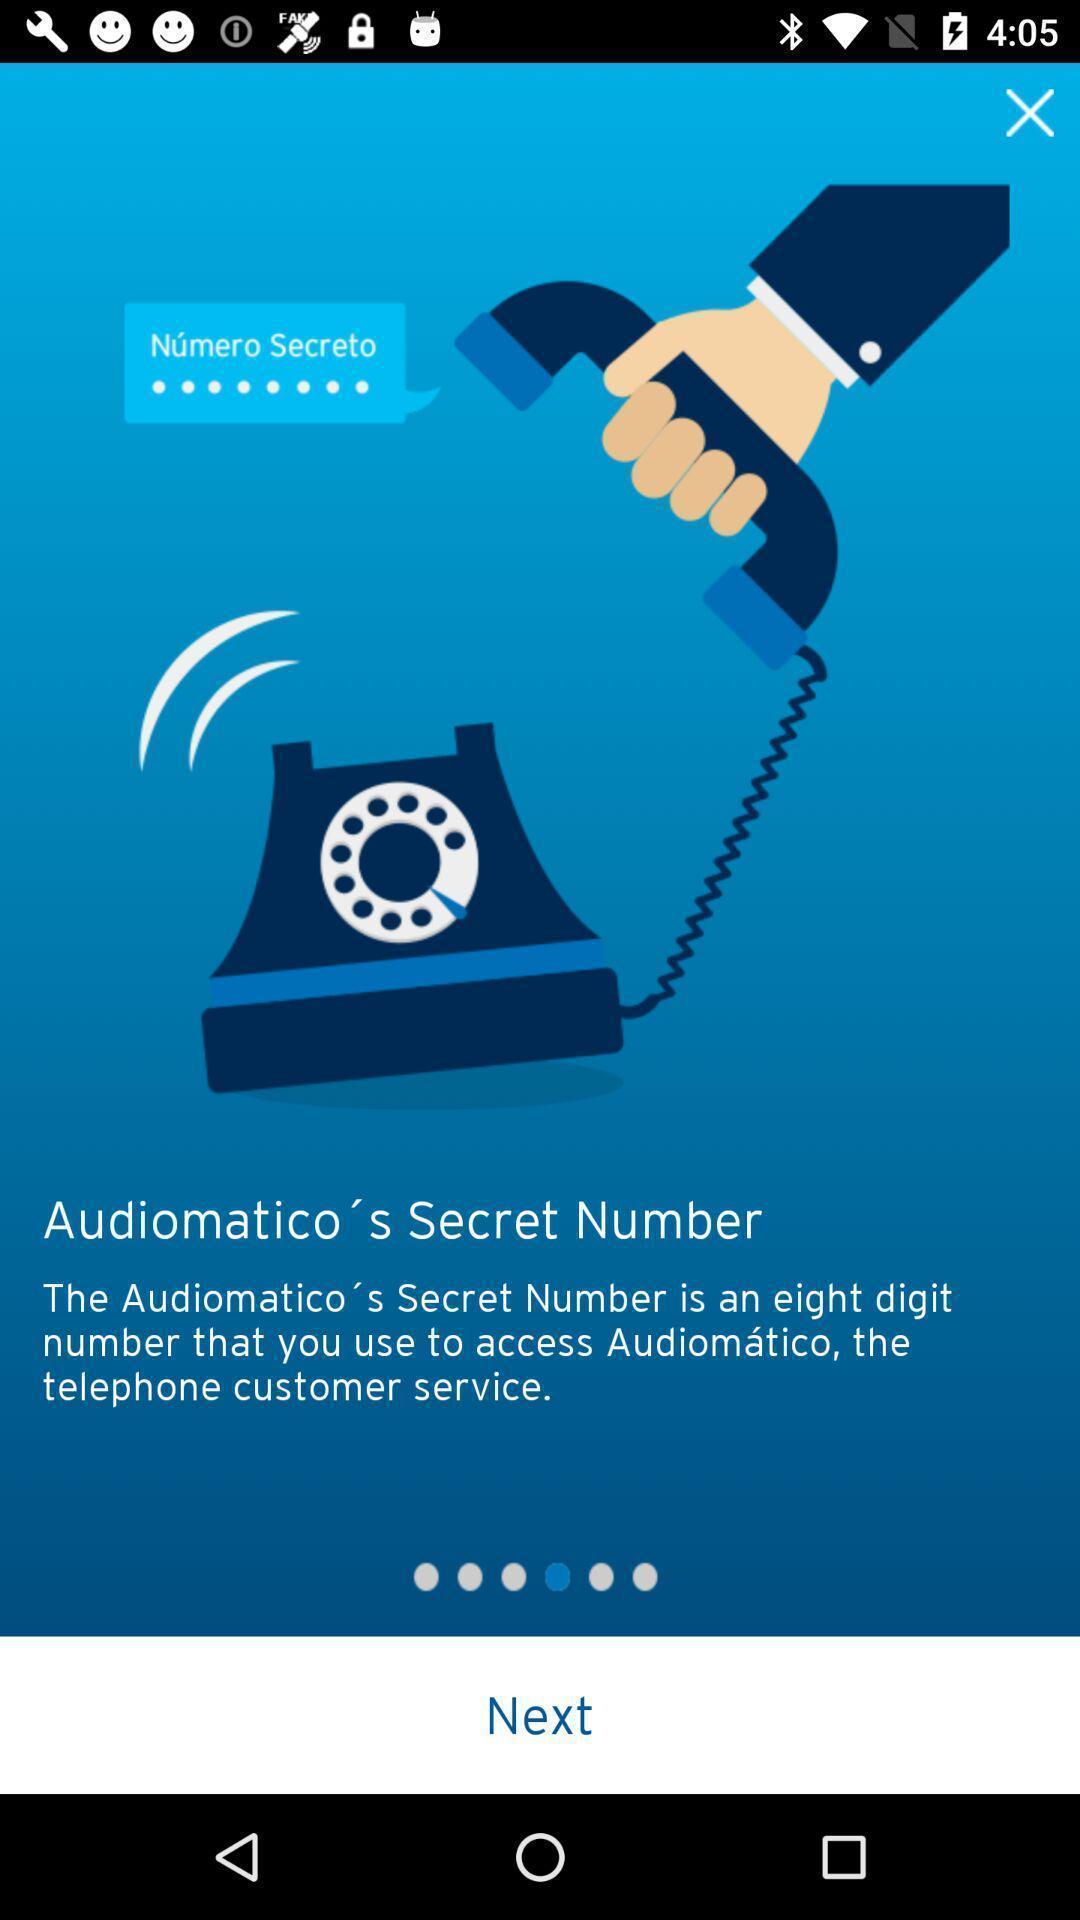Describe the content in this image. Start page of a secret number app. 